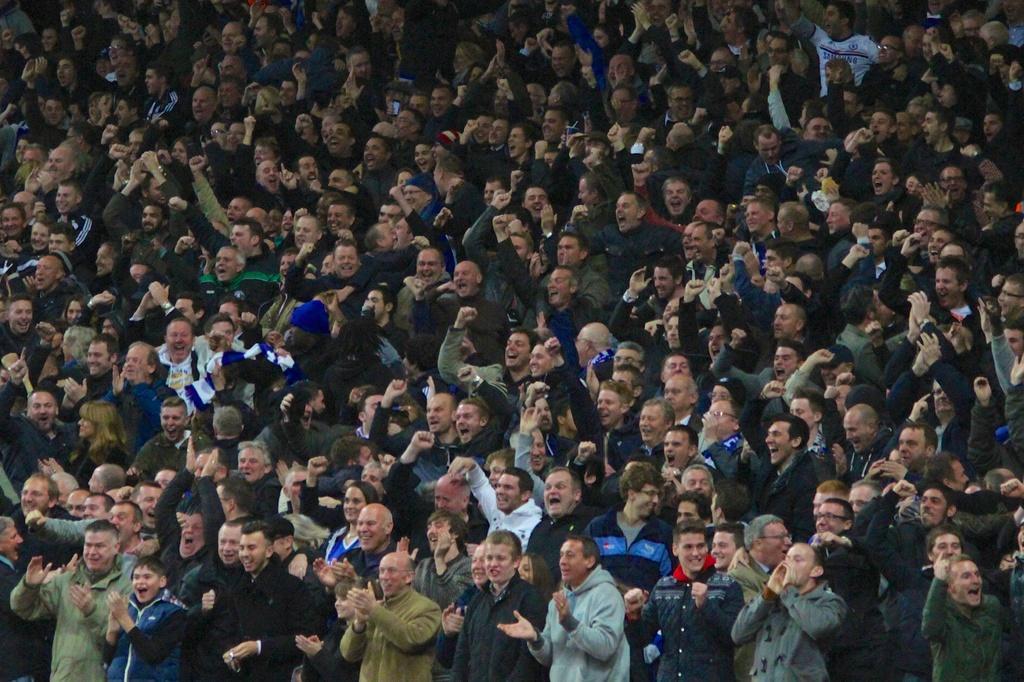In one or two sentences, can you explain what this image depicts? In the foreground of this image, there is the crowd cheering. 